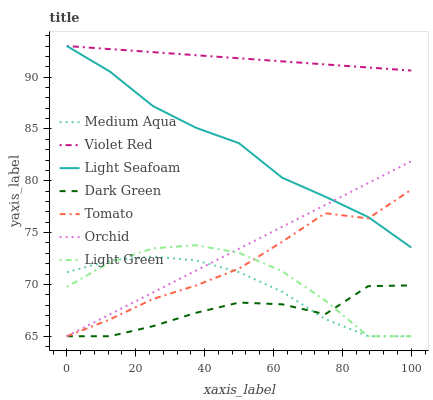Does Dark Green have the minimum area under the curve?
Answer yes or no. Yes. Does Violet Red have the maximum area under the curve?
Answer yes or no. Yes. Does Violet Red have the minimum area under the curve?
Answer yes or no. No. Does Dark Green have the maximum area under the curve?
Answer yes or no. No. Is Violet Red the smoothest?
Answer yes or no. Yes. Is Dark Green the roughest?
Answer yes or no. Yes. Is Dark Green the smoothest?
Answer yes or no. No. Is Violet Red the roughest?
Answer yes or no. No. Does Tomato have the lowest value?
Answer yes or no. Yes. Does Violet Red have the lowest value?
Answer yes or no. No. Does Light Seafoam have the highest value?
Answer yes or no. Yes. Does Dark Green have the highest value?
Answer yes or no. No. Is Dark Green less than Violet Red?
Answer yes or no. Yes. Is Light Seafoam greater than Light Green?
Answer yes or no. Yes. Does Medium Aqua intersect Dark Green?
Answer yes or no. Yes. Is Medium Aqua less than Dark Green?
Answer yes or no. No. Is Medium Aqua greater than Dark Green?
Answer yes or no. No. Does Dark Green intersect Violet Red?
Answer yes or no. No. 